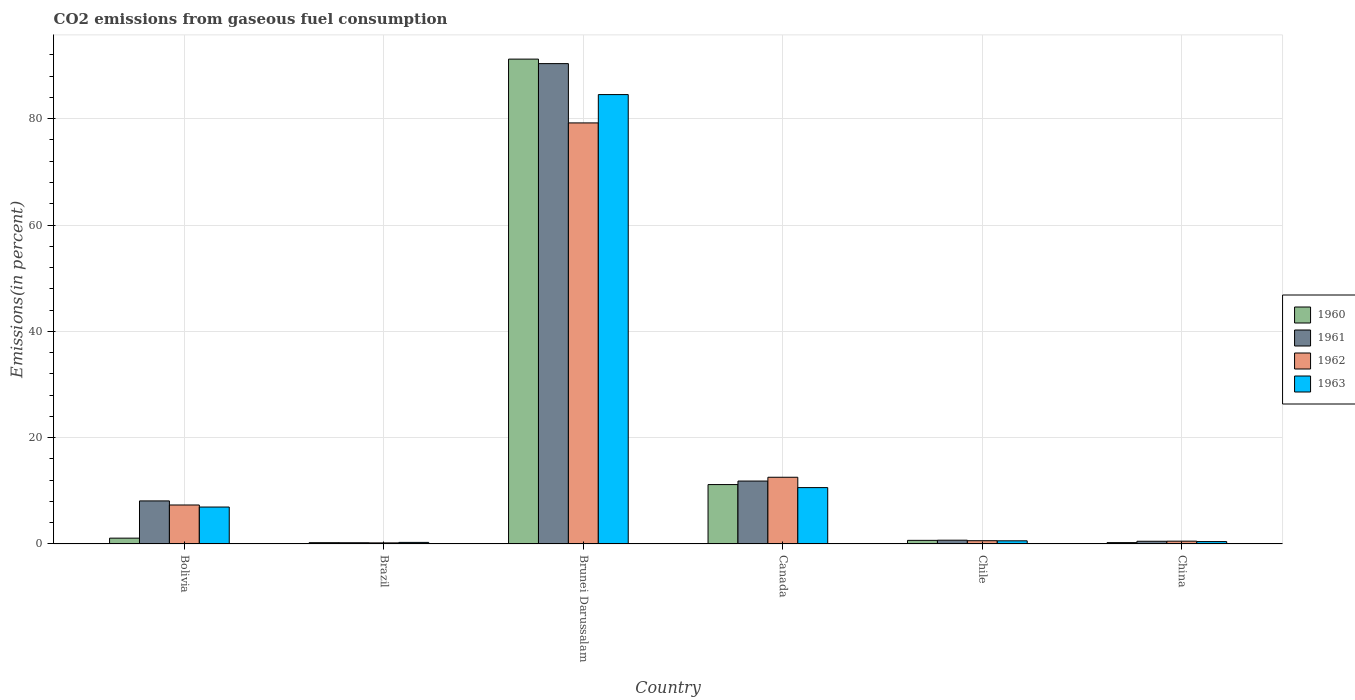How many different coloured bars are there?
Your answer should be compact. 4. Are the number of bars per tick equal to the number of legend labels?
Give a very brief answer. Yes. Are the number of bars on each tick of the X-axis equal?
Offer a very short reply. Yes. How many bars are there on the 2nd tick from the left?
Your answer should be very brief. 4. What is the label of the 3rd group of bars from the left?
Your response must be concise. Brunei Darussalam. In how many cases, is the number of bars for a given country not equal to the number of legend labels?
Offer a terse response. 0. What is the total CO2 emitted in 1963 in Brazil?
Offer a very short reply. 0.3. Across all countries, what is the maximum total CO2 emitted in 1962?
Your answer should be very brief. 79.21. Across all countries, what is the minimum total CO2 emitted in 1960?
Your response must be concise. 0.24. In which country was the total CO2 emitted in 1960 maximum?
Provide a succinct answer. Brunei Darussalam. What is the total total CO2 emitted in 1960 in the graph?
Make the answer very short. 104.66. What is the difference between the total CO2 emitted in 1963 in Brazil and that in Chile?
Offer a terse response. -0.29. What is the difference between the total CO2 emitted in 1961 in Brazil and the total CO2 emitted in 1962 in Canada?
Provide a short and direct response. -12.32. What is the average total CO2 emitted in 1962 per country?
Provide a succinct answer. 16.74. What is the difference between the total CO2 emitted of/in 1960 and total CO2 emitted of/in 1961 in Chile?
Provide a short and direct response. -0.03. In how many countries, is the total CO2 emitted in 1960 greater than 32 %?
Your answer should be compact. 1. What is the ratio of the total CO2 emitted in 1962 in Bolivia to that in China?
Provide a short and direct response. 13.89. Is the total CO2 emitted in 1963 in Brunei Darussalam less than that in China?
Offer a very short reply. No. Is the difference between the total CO2 emitted in 1960 in Brazil and Chile greater than the difference between the total CO2 emitted in 1961 in Brazil and Chile?
Provide a short and direct response. Yes. What is the difference between the highest and the second highest total CO2 emitted in 1960?
Your answer should be compact. 10.08. What is the difference between the highest and the lowest total CO2 emitted in 1961?
Give a very brief answer. 90.13. In how many countries, is the total CO2 emitted in 1963 greater than the average total CO2 emitted in 1963 taken over all countries?
Offer a very short reply. 1. Is it the case that in every country, the sum of the total CO2 emitted in 1963 and total CO2 emitted in 1961 is greater than the sum of total CO2 emitted in 1962 and total CO2 emitted in 1960?
Offer a very short reply. No. How many bars are there?
Provide a succinct answer. 24. Are all the bars in the graph horizontal?
Provide a succinct answer. No. How many countries are there in the graph?
Make the answer very short. 6. What is the difference between two consecutive major ticks on the Y-axis?
Your answer should be compact. 20. Does the graph contain any zero values?
Provide a succinct answer. No. What is the title of the graph?
Ensure brevity in your answer.  CO2 emissions from gaseous fuel consumption. What is the label or title of the X-axis?
Keep it short and to the point. Country. What is the label or title of the Y-axis?
Make the answer very short. Emissions(in percent). What is the Emissions(in percent) in 1960 in Bolivia?
Your answer should be compact. 1.09. What is the Emissions(in percent) in 1961 in Bolivia?
Provide a short and direct response. 8.1. What is the Emissions(in percent) in 1962 in Bolivia?
Ensure brevity in your answer.  7.33. What is the Emissions(in percent) in 1963 in Bolivia?
Your answer should be compact. 6.95. What is the Emissions(in percent) in 1960 in Brazil?
Give a very brief answer. 0.24. What is the Emissions(in percent) in 1961 in Brazil?
Provide a short and direct response. 0.23. What is the Emissions(in percent) of 1962 in Brazil?
Keep it short and to the point. 0.2. What is the Emissions(in percent) in 1963 in Brazil?
Your response must be concise. 0.3. What is the Emissions(in percent) of 1960 in Brunei Darussalam?
Give a very brief answer. 91.21. What is the Emissions(in percent) of 1961 in Brunei Darussalam?
Provide a short and direct response. 90.36. What is the Emissions(in percent) in 1962 in Brunei Darussalam?
Your answer should be very brief. 79.21. What is the Emissions(in percent) of 1963 in Brunei Darussalam?
Give a very brief answer. 84.54. What is the Emissions(in percent) in 1960 in Canada?
Provide a short and direct response. 11.17. What is the Emissions(in percent) in 1961 in Canada?
Provide a succinct answer. 11.84. What is the Emissions(in percent) of 1962 in Canada?
Provide a short and direct response. 12.55. What is the Emissions(in percent) in 1963 in Canada?
Your answer should be compact. 10.6. What is the Emissions(in percent) of 1960 in Chile?
Make the answer very short. 0.68. What is the Emissions(in percent) of 1961 in Chile?
Give a very brief answer. 0.71. What is the Emissions(in percent) of 1962 in Chile?
Offer a very short reply. 0.61. What is the Emissions(in percent) of 1963 in Chile?
Your answer should be very brief. 0.59. What is the Emissions(in percent) of 1960 in China?
Make the answer very short. 0.26. What is the Emissions(in percent) in 1961 in China?
Provide a succinct answer. 0.51. What is the Emissions(in percent) in 1962 in China?
Provide a succinct answer. 0.53. What is the Emissions(in percent) in 1963 in China?
Give a very brief answer. 0.45. Across all countries, what is the maximum Emissions(in percent) of 1960?
Ensure brevity in your answer.  91.21. Across all countries, what is the maximum Emissions(in percent) of 1961?
Provide a short and direct response. 90.36. Across all countries, what is the maximum Emissions(in percent) of 1962?
Keep it short and to the point. 79.21. Across all countries, what is the maximum Emissions(in percent) in 1963?
Give a very brief answer. 84.54. Across all countries, what is the minimum Emissions(in percent) of 1960?
Offer a very short reply. 0.24. Across all countries, what is the minimum Emissions(in percent) in 1961?
Your answer should be very brief. 0.23. Across all countries, what is the minimum Emissions(in percent) in 1962?
Provide a succinct answer. 0.2. Across all countries, what is the minimum Emissions(in percent) of 1963?
Your answer should be compact. 0.3. What is the total Emissions(in percent) of 1960 in the graph?
Make the answer very short. 104.66. What is the total Emissions(in percent) in 1961 in the graph?
Offer a terse response. 111.75. What is the total Emissions(in percent) of 1962 in the graph?
Give a very brief answer. 100.44. What is the total Emissions(in percent) in 1963 in the graph?
Ensure brevity in your answer.  103.42. What is the difference between the Emissions(in percent) in 1960 in Bolivia and that in Brazil?
Keep it short and to the point. 0.85. What is the difference between the Emissions(in percent) of 1961 in Bolivia and that in Brazil?
Provide a succinct answer. 7.87. What is the difference between the Emissions(in percent) of 1962 in Bolivia and that in Brazil?
Your response must be concise. 7.13. What is the difference between the Emissions(in percent) of 1963 in Bolivia and that in Brazil?
Keep it short and to the point. 6.65. What is the difference between the Emissions(in percent) of 1960 in Bolivia and that in Brunei Darussalam?
Make the answer very short. -90.11. What is the difference between the Emissions(in percent) of 1961 in Bolivia and that in Brunei Darussalam?
Make the answer very short. -82.26. What is the difference between the Emissions(in percent) in 1962 in Bolivia and that in Brunei Darussalam?
Provide a succinct answer. -71.87. What is the difference between the Emissions(in percent) in 1963 in Bolivia and that in Brunei Darussalam?
Offer a terse response. -77.59. What is the difference between the Emissions(in percent) in 1960 in Bolivia and that in Canada?
Your answer should be compact. -10.08. What is the difference between the Emissions(in percent) of 1961 in Bolivia and that in Canada?
Offer a terse response. -3.74. What is the difference between the Emissions(in percent) of 1962 in Bolivia and that in Canada?
Make the answer very short. -5.22. What is the difference between the Emissions(in percent) in 1963 in Bolivia and that in Canada?
Make the answer very short. -3.65. What is the difference between the Emissions(in percent) in 1960 in Bolivia and that in Chile?
Offer a terse response. 0.42. What is the difference between the Emissions(in percent) of 1961 in Bolivia and that in Chile?
Offer a very short reply. 7.39. What is the difference between the Emissions(in percent) in 1962 in Bolivia and that in Chile?
Ensure brevity in your answer.  6.72. What is the difference between the Emissions(in percent) in 1963 in Bolivia and that in Chile?
Your answer should be compact. 6.36. What is the difference between the Emissions(in percent) in 1960 in Bolivia and that in China?
Offer a very short reply. 0.84. What is the difference between the Emissions(in percent) of 1961 in Bolivia and that in China?
Ensure brevity in your answer.  7.59. What is the difference between the Emissions(in percent) in 1962 in Bolivia and that in China?
Ensure brevity in your answer.  6.81. What is the difference between the Emissions(in percent) of 1963 in Bolivia and that in China?
Make the answer very short. 6.5. What is the difference between the Emissions(in percent) in 1960 in Brazil and that in Brunei Darussalam?
Provide a short and direct response. -90.97. What is the difference between the Emissions(in percent) in 1961 in Brazil and that in Brunei Darussalam?
Offer a very short reply. -90.13. What is the difference between the Emissions(in percent) of 1962 in Brazil and that in Brunei Darussalam?
Your response must be concise. -79. What is the difference between the Emissions(in percent) of 1963 in Brazil and that in Brunei Darussalam?
Offer a very short reply. -84.24. What is the difference between the Emissions(in percent) of 1960 in Brazil and that in Canada?
Provide a succinct answer. -10.93. What is the difference between the Emissions(in percent) in 1961 in Brazil and that in Canada?
Give a very brief answer. -11.61. What is the difference between the Emissions(in percent) in 1962 in Brazil and that in Canada?
Ensure brevity in your answer.  -12.34. What is the difference between the Emissions(in percent) of 1963 in Brazil and that in Canada?
Your answer should be very brief. -10.31. What is the difference between the Emissions(in percent) in 1960 in Brazil and that in Chile?
Offer a very short reply. -0.44. What is the difference between the Emissions(in percent) of 1961 in Brazil and that in Chile?
Provide a succinct answer. -0.48. What is the difference between the Emissions(in percent) in 1962 in Brazil and that in Chile?
Give a very brief answer. -0.41. What is the difference between the Emissions(in percent) in 1963 in Brazil and that in Chile?
Make the answer very short. -0.29. What is the difference between the Emissions(in percent) in 1960 in Brazil and that in China?
Provide a short and direct response. -0.01. What is the difference between the Emissions(in percent) of 1961 in Brazil and that in China?
Make the answer very short. -0.28. What is the difference between the Emissions(in percent) in 1962 in Brazil and that in China?
Keep it short and to the point. -0.32. What is the difference between the Emissions(in percent) in 1963 in Brazil and that in China?
Ensure brevity in your answer.  -0.15. What is the difference between the Emissions(in percent) of 1960 in Brunei Darussalam and that in Canada?
Provide a short and direct response. 80.03. What is the difference between the Emissions(in percent) of 1961 in Brunei Darussalam and that in Canada?
Your answer should be very brief. 78.52. What is the difference between the Emissions(in percent) of 1962 in Brunei Darussalam and that in Canada?
Your response must be concise. 66.66. What is the difference between the Emissions(in percent) of 1963 in Brunei Darussalam and that in Canada?
Your response must be concise. 73.93. What is the difference between the Emissions(in percent) in 1960 in Brunei Darussalam and that in Chile?
Offer a very short reply. 90.53. What is the difference between the Emissions(in percent) in 1961 in Brunei Darussalam and that in Chile?
Your answer should be very brief. 89.65. What is the difference between the Emissions(in percent) in 1962 in Brunei Darussalam and that in Chile?
Give a very brief answer. 78.59. What is the difference between the Emissions(in percent) in 1963 in Brunei Darussalam and that in Chile?
Offer a terse response. 83.94. What is the difference between the Emissions(in percent) in 1960 in Brunei Darussalam and that in China?
Provide a short and direct response. 90.95. What is the difference between the Emissions(in percent) of 1961 in Brunei Darussalam and that in China?
Keep it short and to the point. 89.85. What is the difference between the Emissions(in percent) of 1962 in Brunei Darussalam and that in China?
Your answer should be compact. 78.68. What is the difference between the Emissions(in percent) in 1963 in Brunei Darussalam and that in China?
Give a very brief answer. 84.09. What is the difference between the Emissions(in percent) of 1960 in Canada and that in Chile?
Offer a very short reply. 10.49. What is the difference between the Emissions(in percent) in 1961 in Canada and that in Chile?
Your answer should be compact. 11.13. What is the difference between the Emissions(in percent) in 1962 in Canada and that in Chile?
Your answer should be compact. 11.93. What is the difference between the Emissions(in percent) in 1963 in Canada and that in Chile?
Your answer should be very brief. 10.01. What is the difference between the Emissions(in percent) in 1960 in Canada and that in China?
Keep it short and to the point. 10.92. What is the difference between the Emissions(in percent) of 1961 in Canada and that in China?
Give a very brief answer. 11.33. What is the difference between the Emissions(in percent) in 1962 in Canada and that in China?
Offer a terse response. 12.02. What is the difference between the Emissions(in percent) in 1963 in Canada and that in China?
Your answer should be compact. 10.15. What is the difference between the Emissions(in percent) in 1960 in Chile and that in China?
Make the answer very short. 0.42. What is the difference between the Emissions(in percent) of 1961 in Chile and that in China?
Give a very brief answer. 0.2. What is the difference between the Emissions(in percent) of 1962 in Chile and that in China?
Ensure brevity in your answer.  0.09. What is the difference between the Emissions(in percent) in 1963 in Chile and that in China?
Your answer should be very brief. 0.14. What is the difference between the Emissions(in percent) in 1960 in Bolivia and the Emissions(in percent) in 1961 in Brazil?
Offer a very short reply. 0.86. What is the difference between the Emissions(in percent) of 1960 in Bolivia and the Emissions(in percent) of 1962 in Brazil?
Provide a short and direct response. 0.89. What is the difference between the Emissions(in percent) in 1960 in Bolivia and the Emissions(in percent) in 1963 in Brazil?
Offer a terse response. 0.8. What is the difference between the Emissions(in percent) in 1961 in Bolivia and the Emissions(in percent) in 1962 in Brazil?
Offer a very short reply. 7.89. What is the difference between the Emissions(in percent) of 1961 in Bolivia and the Emissions(in percent) of 1963 in Brazil?
Keep it short and to the point. 7.8. What is the difference between the Emissions(in percent) in 1962 in Bolivia and the Emissions(in percent) in 1963 in Brazil?
Your response must be concise. 7.04. What is the difference between the Emissions(in percent) of 1960 in Bolivia and the Emissions(in percent) of 1961 in Brunei Darussalam?
Provide a short and direct response. -89.27. What is the difference between the Emissions(in percent) of 1960 in Bolivia and the Emissions(in percent) of 1962 in Brunei Darussalam?
Give a very brief answer. -78.11. What is the difference between the Emissions(in percent) of 1960 in Bolivia and the Emissions(in percent) of 1963 in Brunei Darussalam?
Your answer should be very brief. -83.44. What is the difference between the Emissions(in percent) of 1961 in Bolivia and the Emissions(in percent) of 1962 in Brunei Darussalam?
Your answer should be compact. -71.11. What is the difference between the Emissions(in percent) in 1961 in Bolivia and the Emissions(in percent) in 1963 in Brunei Darussalam?
Make the answer very short. -76.44. What is the difference between the Emissions(in percent) in 1962 in Bolivia and the Emissions(in percent) in 1963 in Brunei Darussalam?
Provide a succinct answer. -77.2. What is the difference between the Emissions(in percent) in 1960 in Bolivia and the Emissions(in percent) in 1961 in Canada?
Provide a succinct answer. -10.74. What is the difference between the Emissions(in percent) of 1960 in Bolivia and the Emissions(in percent) of 1962 in Canada?
Provide a succinct answer. -11.45. What is the difference between the Emissions(in percent) in 1960 in Bolivia and the Emissions(in percent) in 1963 in Canada?
Provide a short and direct response. -9.51. What is the difference between the Emissions(in percent) of 1961 in Bolivia and the Emissions(in percent) of 1962 in Canada?
Your response must be concise. -4.45. What is the difference between the Emissions(in percent) in 1961 in Bolivia and the Emissions(in percent) in 1963 in Canada?
Make the answer very short. -2.5. What is the difference between the Emissions(in percent) in 1962 in Bolivia and the Emissions(in percent) in 1963 in Canada?
Provide a succinct answer. -3.27. What is the difference between the Emissions(in percent) of 1960 in Bolivia and the Emissions(in percent) of 1961 in Chile?
Offer a very short reply. 0.39. What is the difference between the Emissions(in percent) of 1960 in Bolivia and the Emissions(in percent) of 1962 in Chile?
Give a very brief answer. 0.48. What is the difference between the Emissions(in percent) in 1960 in Bolivia and the Emissions(in percent) in 1963 in Chile?
Offer a very short reply. 0.5. What is the difference between the Emissions(in percent) of 1961 in Bolivia and the Emissions(in percent) of 1962 in Chile?
Keep it short and to the point. 7.48. What is the difference between the Emissions(in percent) of 1961 in Bolivia and the Emissions(in percent) of 1963 in Chile?
Give a very brief answer. 7.51. What is the difference between the Emissions(in percent) in 1962 in Bolivia and the Emissions(in percent) in 1963 in Chile?
Your response must be concise. 6.74. What is the difference between the Emissions(in percent) of 1960 in Bolivia and the Emissions(in percent) of 1961 in China?
Your response must be concise. 0.58. What is the difference between the Emissions(in percent) in 1960 in Bolivia and the Emissions(in percent) in 1962 in China?
Offer a terse response. 0.57. What is the difference between the Emissions(in percent) in 1960 in Bolivia and the Emissions(in percent) in 1963 in China?
Provide a short and direct response. 0.65. What is the difference between the Emissions(in percent) of 1961 in Bolivia and the Emissions(in percent) of 1962 in China?
Provide a succinct answer. 7.57. What is the difference between the Emissions(in percent) of 1961 in Bolivia and the Emissions(in percent) of 1963 in China?
Offer a terse response. 7.65. What is the difference between the Emissions(in percent) of 1962 in Bolivia and the Emissions(in percent) of 1963 in China?
Keep it short and to the point. 6.88. What is the difference between the Emissions(in percent) in 1960 in Brazil and the Emissions(in percent) in 1961 in Brunei Darussalam?
Give a very brief answer. -90.12. What is the difference between the Emissions(in percent) of 1960 in Brazil and the Emissions(in percent) of 1962 in Brunei Darussalam?
Keep it short and to the point. -78.97. What is the difference between the Emissions(in percent) of 1960 in Brazil and the Emissions(in percent) of 1963 in Brunei Darussalam?
Your response must be concise. -84.29. What is the difference between the Emissions(in percent) in 1961 in Brazil and the Emissions(in percent) in 1962 in Brunei Darussalam?
Provide a succinct answer. -78.98. What is the difference between the Emissions(in percent) in 1961 in Brazil and the Emissions(in percent) in 1963 in Brunei Darussalam?
Offer a very short reply. -84.31. What is the difference between the Emissions(in percent) of 1962 in Brazil and the Emissions(in percent) of 1963 in Brunei Darussalam?
Offer a terse response. -84.33. What is the difference between the Emissions(in percent) of 1960 in Brazil and the Emissions(in percent) of 1961 in Canada?
Offer a very short reply. -11.59. What is the difference between the Emissions(in percent) in 1960 in Brazil and the Emissions(in percent) in 1962 in Canada?
Offer a very short reply. -12.31. What is the difference between the Emissions(in percent) of 1960 in Brazil and the Emissions(in percent) of 1963 in Canada?
Provide a short and direct response. -10.36. What is the difference between the Emissions(in percent) in 1961 in Brazil and the Emissions(in percent) in 1962 in Canada?
Provide a short and direct response. -12.32. What is the difference between the Emissions(in percent) in 1961 in Brazil and the Emissions(in percent) in 1963 in Canada?
Provide a succinct answer. -10.37. What is the difference between the Emissions(in percent) of 1962 in Brazil and the Emissions(in percent) of 1963 in Canada?
Your response must be concise. -10.4. What is the difference between the Emissions(in percent) in 1960 in Brazil and the Emissions(in percent) in 1961 in Chile?
Your answer should be very brief. -0.47. What is the difference between the Emissions(in percent) of 1960 in Brazil and the Emissions(in percent) of 1962 in Chile?
Your answer should be very brief. -0.37. What is the difference between the Emissions(in percent) in 1960 in Brazil and the Emissions(in percent) in 1963 in Chile?
Provide a succinct answer. -0.35. What is the difference between the Emissions(in percent) in 1961 in Brazil and the Emissions(in percent) in 1962 in Chile?
Your answer should be compact. -0.38. What is the difference between the Emissions(in percent) in 1961 in Brazil and the Emissions(in percent) in 1963 in Chile?
Your answer should be very brief. -0.36. What is the difference between the Emissions(in percent) of 1962 in Brazil and the Emissions(in percent) of 1963 in Chile?
Keep it short and to the point. -0.39. What is the difference between the Emissions(in percent) in 1960 in Brazil and the Emissions(in percent) in 1961 in China?
Your answer should be compact. -0.27. What is the difference between the Emissions(in percent) of 1960 in Brazil and the Emissions(in percent) of 1962 in China?
Your response must be concise. -0.29. What is the difference between the Emissions(in percent) in 1960 in Brazil and the Emissions(in percent) in 1963 in China?
Make the answer very short. -0.21. What is the difference between the Emissions(in percent) in 1961 in Brazil and the Emissions(in percent) in 1962 in China?
Ensure brevity in your answer.  -0.3. What is the difference between the Emissions(in percent) of 1961 in Brazil and the Emissions(in percent) of 1963 in China?
Keep it short and to the point. -0.22. What is the difference between the Emissions(in percent) of 1962 in Brazil and the Emissions(in percent) of 1963 in China?
Your response must be concise. -0.24. What is the difference between the Emissions(in percent) in 1960 in Brunei Darussalam and the Emissions(in percent) in 1961 in Canada?
Keep it short and to the point. 79.37. What is the difference between the Emissions(in percent) of 1960 in Brunei Darussalam and the Emissions(in percent) of 1962 in Canada?
Provide a succinct answer. 78.66. What is the difference between the Emissions(in percent) in 1960 in Brunei Darussalam and the Emissions(in percent) in 1963 in Canada?
Your response must be concise. 80.61. What is the difference between the Emissions(in percent) in 1961 in Brunei Darussalam and the Emissions(in percent) in 1962 in Canada?
Offer a terse response. 77.81. What is the difference between the Emissions(in percent) of 1961 in Brunei Darussalam and the Emissions(in percent) of 1963 in Canada?
Offer a very short reply. 79.76. What is the difference between the Emissions(in percent) of 1962 in Brunei Darussalam and the Emissions(in percent) of 1963 in Canada?
Give a very brief answer. 68.61. What is the difference between the Emissions(in percent) of 1960 in Brunei Darussalam and the Emissions(in percent) of 1961 in Chile?
Your answer should be very brief. 90.5. What is the difference between the Emissions(in percent) of 1960 in Brunei Darussalam and the Emissions(in percent) of 1962 in Chile?
Ensure brevity in your answer.  90.59. What is the difference between the Emissions(in percent) in 1960 in Brunei Darussalam and the Emissions(in percent) in 1963 in Chile?
Provide a succinct answer. 90.62. What is the difference between the Emissions(in percent) in 1961 in Brunei Darussalam and the Emissions(in percent) in 1962 in Chile?
Your response must be concise. 89.75. What is the difference between the Emissions(in percent) in 1961 in Brunei Darussalam and the Emissions(in percent) in 1963 in Chile?
Ensure brevity in your answer.  89.77. What is the difference between the Emissions(in percent) of 1962 in Brunei Darussalam and the Emissions(in percent) of 1963 in Chile?
Give a very brief answer. 78.62. What is the difference between the Emissions(in percent) of 1960 in Brunei Darussalam and the Emissions(in percent) of 1961 in China?
Offer a terse response. 90.7. What is the difference between the Emissions(in percent) in 1960 in Brunei Darussalam and the Emissions(in percent) in 1962 in China?
Keep it short and to the point. 90.68. What is the difference between the Emissions(in percent) of 1960 in Brunei Darussalam and the Emissions(in percent) of 1963 in China?
Give a very brief answer. 90.76. What is the difference between the Emissions(in percent) in 1961 in Brunei Darussalam and the Emissions(in percent) in 1962 in China?
Give a very brief answer. 89.83. What is the difference between the Emissions(in percent) in 1961 in Brunei Darussalam and the Emissions(in percent) in 1963 in China?
Keep it short and to the point. 89.91. What is the difference between the Emissions(in percent) in 1962 in Brunei Darussalam and the Emissions(in percent) in 1963 in China?
Make the answer very short. 78.76. What is the difference between the Emissions(in percent) in 1960 in Canada and the Emissions(in percent) in 1961 in Chile?
Provide a short and direct response. 10.46. What is the difference between the Emissions(in percent) in 1960 in Canada and the Emissions(in percent) in 1962 in Chile?
Your answer should be very brief. 10.56. What is the difference between the Emissions(in percent) in 1960 in Canada and the Emissions(in percent) in 1963 in Chile?
Your answer should be compact. 10.58. What is the difference between the Emissions(in percent) of 1961 in Canada and the Emissions(in percent) of 1962 in Chile?
Give a very brief answer. 11.22. What is the difference between the Emissions(in percent) of 1961 in Canada and the Emissions(in percent) of 1963 in Chile?
Offer a very short reply. 11.25. What is the difference between the Emissions(in percent) of 1962 in Canada and the Emissions(in percent) of 1963 in Chile?
Make the answer very short. 11.96. What is the difference between the Emissions(in percent) of 1960 in Canada and the Emissions(in percent) of 1961 in China?
Provide a succinct answer. 10.66. What is the difference between the Emissions(in percent) in 1960 in Canada and the Emissions(in percent) in 1962 in China?
Keep it short and to the point. 10.65. What is the difference between the Emissions(in percent) of 1960 in Canada and the Emissions(in percent) of 1963 in China?
Your response must be concise. 10.73. What is the difference between the Emissions(in percent) in 1961 in Canada and the Emissions(in percent) in 1962 in China?
Your answer should be compact. 11.31. What is the difference between the Emissions(in percent) in 1961 in Canada and the Emissions(in percent) in 1963 in China?
Provide a short and direct response. 11.39. What is the difference between the Emissions(in percent) of 1962 in Canada and the Emissions(in percent) of 1963 in China?
Provide a short and direct response. 12.1. What is the difference between the Emissions(in percent) in 1960 in Chile and the Emissions(in percent) in 1961 in China?
Your answer should be very brief. 0.17. What is the difference between the Emissions(in percent) in 1960 in Chile and the Emissions(in percent) in 1962 in China?
Ensure brevity in your answer.  0.15. What is the difference between the Emissions(in percent) in 1960 in Chile and the Emissions(in percent) in 1963 in China?
Give a very brief answer. 0.23. What is the difference between the Emissions(in percent) of 1961 in Chile and the Emissions(in percent) of 1962 in China?
Your answer should be very brief. 0.18. What is the difference between the Emissions(in percent) of 1961 in Chile and the Emissions(in percent) of 1963 in China?
Give a very brief answer. 0.26. What is the difference between the Emissions(in percent) in 1962 in Chile and the Emissions(in percent) in 1963 in China?
Make the answer very short. 0.17. What is the average Emissions(in percent) of 1960 per country?
Give a very brief answer. 17.44. What is the average Emissions(in percent) in 1961 per country?
Make the answer very short. 18.62. What is the average Emissions(in percent) in 1962 per country?
Give a very brief answer. 16.74. What is the average Emissions(in percent) of 1963 per country?
Provide a short and direct response. 17.24. What is the difference between the Emissions(in percent) in 1960 and Emissions(in percent) in 1961 in Bolivia?
Your answer should be compact. -7. What is the difference between the Emissions(in percent) in 1960 and Emissions(in percent) in 1962 in Bolivia?
Your answer should be very brief. -6.24. What is the difference between the Emissions(in percent) in 1960 and Emissions(in percent) in 1963 in Bolivia?
Your response must be concise. -5.85. What is the difference between the Emissions(in percent) of 1961 and Emissions(in percent) of 1962 in Bolivia?
Offer a terse response. 0.77. What is the difference between the Emissions(in percent) in 1961 and Emissions(in percent) in 1963 in Bolivia?
Keep it short and to the point. 1.15. What is the difference between the Emissions(in percent) in 1962 and Emissions(in percent) in 1963 in Bolivia?
Provide a short and direct response. 0.38. What is the difference between the Emissions(in percent) in 1960 and Emissions(in percent) in 1961 in Brazil?
Your response must be concise. 0.01. What is the difference between the Emissions(in percent) in 1960 and Emissions(in percent) in 1962 in Brazil?
Keep it short and to the point. 0.04. What is the difference between the Emissions(in percent) of 1960 and Emissions(in percent) of 1963 in Brazil?
Keep it short and to the point. -0.05. What is the difference between the Emissions(in percent) in 1961 and Emissions(in percent) in 1962 in Brazil?
Give a very brief answer. 0.03. What is the difference between the Emissions(in percent) in 1961 and Emissions(in percent) in 1963 in Brazil?
Provide a succinct answer. -0.07. What is the difference between the Emissions(in percent) of 1962 and Emissions(in percent) of 1963 in Brazil?
Offer a terse response. -0.09. What is the difference between the Emissions(in percent) of 1960 and Emissions(in percent) of 1961 in Brunei Darussalam?
Your answer should be very brief. 0.85. What is the difference between the Emissions(in percent) in 1960 and Emissions(in percent) in 1962 in Brunei Darussalam?
Ensure brevity in your answer.  12. What is the difference between the Emissions(in percent) of 1960 and Emissions(in percent) of 1963 in Brunei Darussalam?
Make the answer very short. 6.67. What is the difference between the Emissions(in percent) of 1961 and Emissions(in percent) of 1962 in Brunei Darussalam?
Give a very brief answer. 11.15. What is the difference between the Emissions(in percent) of 1961 and Emissions(in percent) of 1963 in Brunei Darussalam?
Ensure brevity in your answer.  5.83. What is the difference between the Emissions(in percent) in 1962 and Emissions(in percent) in 1963 in Brunei Darussalam?
Give a very brief answer. -5.33. What is the difference between the Emissions(in percent) in 1960 and Emissions(in percent) in 1961 in Canada?
Your answer should be very brief. -0.66. What is the difference between the Emissions(in percent) of 1960 and Emissions(in percent) of 1962 in Canada?
Your answer should be compact. -1.37. What is the difference between the Emissions(in percent) of 1960 and Emissions(in percent) of 1963 in Canada?
Your answer should be very brief. 0.57. What is the difference between the Emissions(in percent) of 1961 and Emissions(in percent) of 1962 in Canada?
Make the answer very short. -0.71. What is the difference between the Emissions(in percent) in 1961 and Emissions(in percent) in 1963 in Canada?
Your answer should be very brief. 1.23. What is the difference between the Emissions(in percent) of 1962 and Emissions(in percent) of 1963 in Canada?
Offer a very short reply. 1.95. What is the difference between the Emissions(in percent) of 1960 and Emissions(in percent) of 1961 in Chile?
Provide a succinct answer. -0.03. What is the difference between the Emissions(in percent) of 1960 and Emissions(in percent) of 1962 in Chile?
Your response must be concise. 0.07. What is the difference between the Emissions(in percent) in 1960 and Emissions(in percent) in 1963 in Chile?
Your response must be concise. 0.09. What is the difference between the Emissions(in percent) of 1961 and Emissions(in percent) of 1962 in Chile?
Provide a succinct answer. 0.1. What is the difference between the Emissions(in percent) of 1961 and Emissions(in percent) of 1963 in Chile?
Make the answer very short. 0.12. What is the difference between the Emissions(in percent) of 1962 and Emissions(in percent) of 1963 in Chile?
Ensure brevity in your answer.  0.02. What is the difference between the Emissions(in percent) of 1960 and Emissions(in percent) of 1961 in China?
Offer a terse response. -0.26. What is the difference between the Emissions(in percent) of 1960 and Emissions(in percent) of 1962 in China?
Your response must be concise. -0.27. What is the difference between the Emissions(in percent) of 1960 and Emissions(in percent) of 1963 in China?
Keep it short and to the point. -0.19. What is the difference between the Emissions(in percent) in 1961 and Emissions(in percent) in 1962 in China?
Make the answer very short. -0.02. What is the difference between the Emissions(in percent) in 1961 and Emissions(in percent) in 1963 in China?
Provide a succinct answer. 0.06. What is the difference between the Emissions(in percent) in 1962 and Emissions(in percent) in 1963 in China?
Keep it short and to the point. 0.08. What is the ratio of the Emissions(in percent) in 1960 in Bolivia to that in Brazil?
Your response must be concise. 4.52. What is the ratio of the Emissions(in percent) in 1961 in Bolivia to that in Brazil?
Give a very brief answer. 35.05. What is the ratio of the Emissions(in percent) of 1962 in Bolivia to that in Brazil?
Your answer should be very brief. 35.79. What is the ratio of the Emissions(in percent) in 1963 in Bolivia to that in Brazil?
Offer a very short reply. 23.42. What is the ratio of the Emissions(in percent) of 1960 in Bolivia to that in Brunei Darussalam?
Your response must be concise. 0.01. What is the ratio of the Emissions(in percent) in 1961 in Bolivia to that in Brunei Darussalam?
Ensure brevity in your answer.  0.09. What is the ratio of the Emissions(in percent) in 1962 in Bolivia to that in Brunei Darussalam?
Provide a short and direct response. 0.09. What is the ratio of the Emissions(in percent) in 1963 in Bolivia to that in Brunei Darussalam?
Give a very brief answer. 0.08. What is the ratio of the Emissions(in percent) of 1960 in Bolivia to that in Canada?
Your answer should be very brief. 0.1. What is the ratio of the Emissions(in percent) in 1961 in Bolivia to that in Canada?
Make the answer very short. 0.68. What is the ratio of the Emissions(in percent) in 1962 in Bolivia to that in Canada?
Provide a short and direct response. 0.58. What is the ratio of the Emissions(in percent) of 1963 in Bolivia to that in Canada?
Keep it short and to the point. 0.66. What is the ratio of the Emissions(in percent) in 1960 in Bolivia to that in Chile?
Your response must be concise. 1.61. What is the ratio of the Emissions(in percent) of 1961 in Bolivia to that in Chile?
Your response must be concise. 11.42. What is the ratio of the Emissions(in percent) of 1962 in Bolivia to that in Chile?
Provide a short and direct response. 11.95. What is the ratio of the Emissions(in percent) of 1963 in Bolivia to that in Chile?
Provide a short and direct response. 11.75. What is the ratio of the Emissions(in percent) in 1960 in Bolivia to that in China?
Your answer should be compact. 4.29. What is the ratio of the Emissions(in percent) of 1961 in Bolivia to that in China?
Offer a very short reply. 15.85. What is the ratio of the Emissions(in percent) of 1962 in Bolivia to that in China?
Provide a succinct answer. 13.89. What is the ratio of the Emissions(in percent) in 1963 in Bolivia to that in China?
Your answer should be very brief. 15.5. What is the ratio of the Emissions(in percent) of 1960 in Brazil to that in Brunei Darussalam?
Your answer should be compact. 0. What is the ratio of the Emissions(in percent) in 1961 in Brazil to that in Brunei Darussalam?
Keep it short and to the point. 0. What is the ratio of the Emissions(in percent) in 1962 in Brazil to that in Brunei Darussalam?
Your answer should be very brief. 0. What is the ratio of the Emissions(in percent) in 1963 in Brazil to that in Brunei Darussalam?
Offer a terse response. 0. What is the ratio of the Emissions(in percent) of 1960 in Brazil to that in Canada?
Keep it short and to the point. 0.02. What is the ratio of the Emissions(in percent) in 1961 in Brazil to that in Canada?
Ensure brevity in your answer.  0.02. What is the ratio of the Emissions(in percent) of 1962 in Brazil to that in Canada?
Your response must be concise. 0.02. What is the ratio of the Emissions(in percent) in 1963 in Brazil to that in Canada?
Make the answer very short. 0.03. What is the ratio of the Emissions(in percent) of 1960 in Brazil to that in Chile?
Make the answer very short. 0.36. What is the ratio of the Emissions(in percent) of 1961 in Brazil to that in Chile?
Provide a succinct answer. 0.33. What is the ratio of the Emissions(in percent) of 1962 in Brazil to that in Chile?
Provide a short and direct response. 0.33. What is the ratio of the Emissions(in percent) in 1963 in Brazil to that in Chile?
Ensure brevity in your answer.  0.5. What is the ratio of the Emissions(in percent) of 1960 in Brazil to that in China?
Keep it short and to the point. 0.95. What is the ratio of the Emissions(in percent) in 1961 in Brazil to that in China?
Your answer should be compact. 0.45. What is the ratio of the Emissions(in percent) of 1962 in Brazil to that in China?
Keep it short and to the point. 0.39. What is the ratio of the Emissions(in percent) in 1963 in Brazil to that in China?
Your answer should be very brief. 0.66. What is the ratio of the Emissions(in percent) in 1960 in Brunei Darussalam to that in Canada?
Ensure brevity in your answer.  8.16. What is the ratio of the Emissions(in percent) of 1961 in Brunei Darussalam to that in Canada?
Offer a terse response. 7.63. What is the ratio of the Emissions(in percent) in 1962 in Brunei Darussalam to that in Canada?
Keep it short and to the point. 6.31. What is the ratio of the Emissions(in percent) in 1963 in Brunei Darussalam to that in Canada?
Provide a short and direct response. 7.97. What is the ratio of the Emissions(in percent) of 1960 in Brunei Darussalam to that in Chile?
Offer a very short reply. 134.22. What is the ratio of the Emissions(in percent) in 1961 in Brunei Darussalam to that in Chile?
Your answer should be very brief. 127.38. What is the ratio of the Emissions(in percent) of 1962 in Brunei Darussalam to that in Chile?
Make the answer very short. 129.02. What is the ratio of the Emissions(in percent) of 1963 in Brunei Darussalam to that in Chile?
Your answer should be compact. 142.9. What is the ratio of the Emissions(in percent) in 1960 in Brunei Darussalam to that in China?
Your response must be concise. 356.97. What is the ratio of the Emissions(in percent) in 1961 in Brunei Darussalam to that in China?
Give a very brief answer. 176.9. What is the ratio of the Emissions(in percent) in 1962 in Brunei Darussalam to that in China?
Offer a terse response. 150.03. What is the ratio of the Emissions(in percent) of 1963 in Brunei Darussalam to that in China?
Make the answer very short. 188.53. What is the ratio of the Emissions(in percent) of 1960 in Canada to that in Chile?
Ensure brevity in your answer.  16.44. What is the ratio of the Emissions(in percent) in 1961 in Canada to that in Chile?
Your answer should be very brief. 16.69. What is the ratio of the Emissions(in percent) of 1962 in Canada to that in Chile?
Give a very brief answer. 20.44. What is the ratio of the Emissions(in percent) of 1963 in Canada to that in Chile?
Keep it short and to the point. 17.92. What is the ratio of the Emissions(in percent) in 1960 in Canada to that in China?
Offer a very short reply. 43.73. What is the ratio of the Emissions(in percent) in 1961 in Canada to that in China?
Ensure brevity in your answer.  23.17. What is the ratio of the Emissions(in percent) in 1962 in Canada to that in China?
Ensure brevity in your answer.  23.77. What is the ratio of the Emissions(in percent) of 1963 in Canada to that in China?
Give a very brief answer. 23.65. What is the ratio of the Emissions(in percent) of 1960 in Chile to that in China?
Keep it short and to the point. 2.66. What is the ratio of the Emissions(in percent) of 1961 in Chile to that in China?
Ensure brevity in your answer.  1.39. What is the ratio of the Emissions(in percent) in 1962 in Chile to that in China?
Your response must be concise. 1.16. What is the ratio of the Emissions(in percent) in 1963 in Chile to that in China?
Offer a terse response. 1.32. What is the difference between the highest and the second highest Emissions(in percent) of 1960?
Offer a terse response. 80.03. What is the difference between the highest and the second highest Emissions(in percent) of 1961?
Provide a succinct answer. 78.52. What is the difference between the highest and the second highest Emissions(in percent) in 1962?
Offer a very short reply. 66.66. What is the difference between the highest and the second highest Emissions(in percent) of 1963?
Offer a terse response. 73.93. What is the difference between the highest and the lowest Emissions(in percent) in 1960?
Ensure brevity in your answer.  90.97. What is the difference between the highest and the lowest Emissions(in percent) in 1961?
Make the answer very short. 90.13. What is the difference between the highest and the lowest Emissions(in percent) in 1962?
Ensure brevity in your answer.  79. What is the difference between the highest and the lowest Emissions(in percent) in 1963?
Provide a succinct answer. 84.24. 